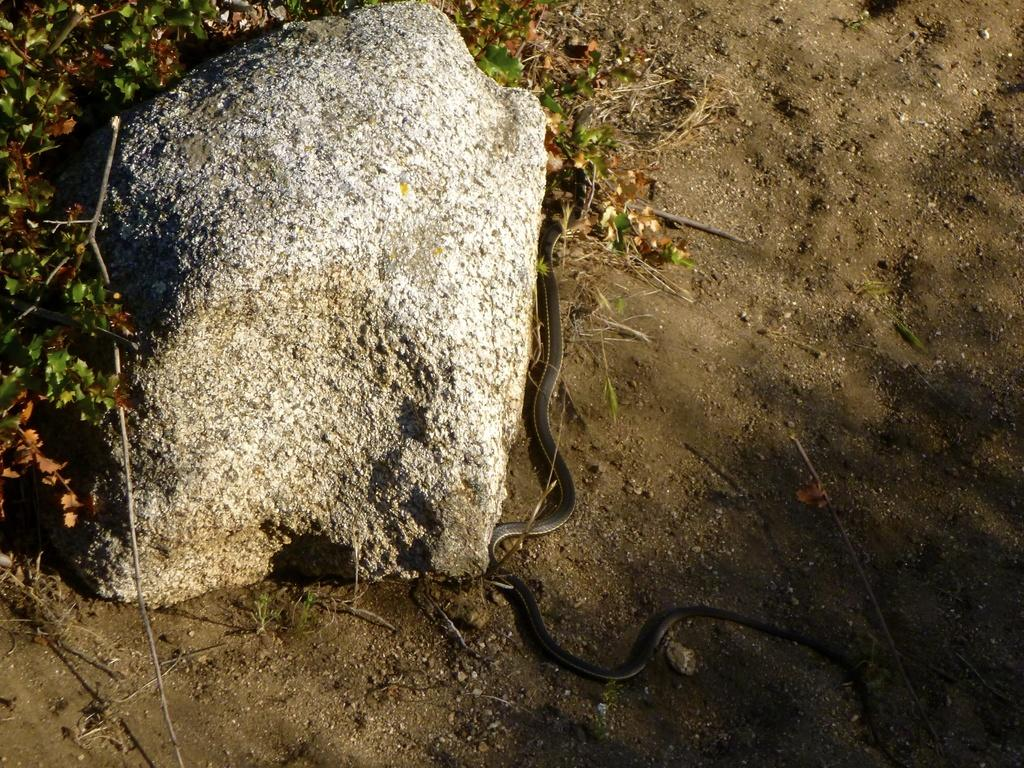What animal can be seen on the path in the image? There is a snake on the path in the image. What is located on the right side of the snake? There is a rock and plants on the right side of the snake in the image. What type of banana is being used as a stamp on the snake's nose in the image? There is no banana or stamp present on the snake's nose in the image. 